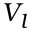Convert formula to latex. <formula><loc_0><loc_0><loc_500><loc_500>V _ { l }</formula> 